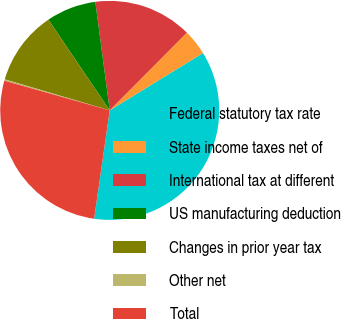<chart> <loc_0><loc_0><loc_500><loc_500><pie_chart><fcel>Federal statutory tax rate<fcel>State income taxes net of<fcel>International tax at different<fcel>US manufacturing deduction<fcel>Changes in prior year tax<fcel>Other net<fcel>Total<nl><fcel>36.05%<fcel>3.79%<fcel>14.54%<fcel>7.37%<fcel>10.96%<fcel>0.21%<fcel>27.09%<nl></chart> 